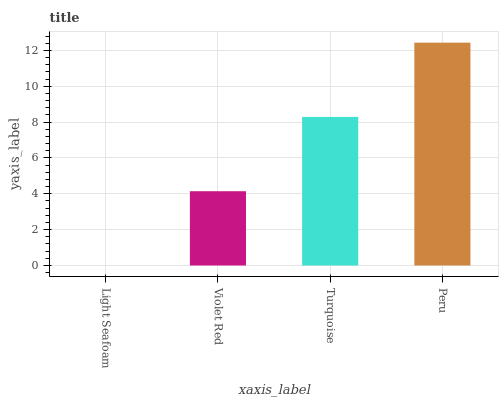Is Light Seafoam the minimum?
Answer yes or no. Yes. Is Peru the maximum?
Answer yes or no. Yes. Is Violet Red the minimum?
Answer yes or no. No. Is Violet Red the maximum?
Answer yes or no. No. Is Violet Red greater than Light Seafoam?
Answer yes or no. Yes. Is Light Seafoam less than Violet Red?
Answer yes or no. Yes. Is Light Seafoam greater than Violet Red?
Answer yes or no. No. Is Violet Red less than Light Seafoam?
Answer yes or no. No. Is Turquoise the high median?
Answer yes or no. Yes. Is Violet Red the low median?
Answer yes or no. Yes. Is Peru the high median?
Answer yes or no. No. Is Peru the low median?
Answer yes or no. No. 